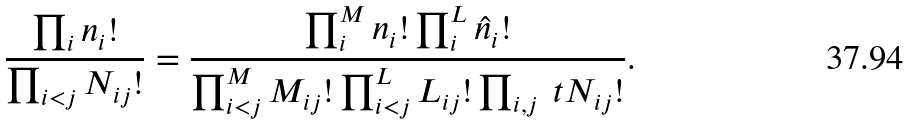<formula> <loc_0><loc_0><loc_500><loc_500>\frac { \prod _ { i } n _ { i } ! } { \prod _ { i < j } N _ { i j } ! } = \frac { \prod _ { i } ^ { M } n _ { i } ! \prod _ { i } ^ { L } \hat { n } _ { i } ! } { \prod _ { i < j } ^ { M } M _ { i j } ! \prod _ { i < j } ^ { L } L _ { i j } ! \prod _ { i , j } \ t N _ { i j } ! } .</formula> 